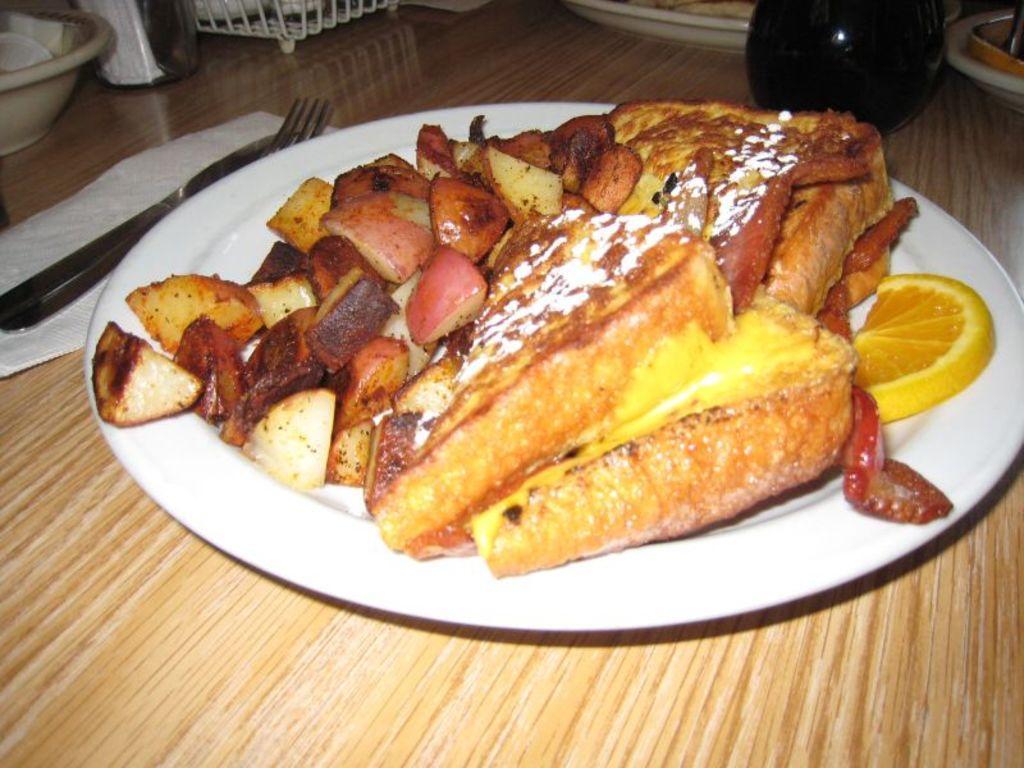Describe this image in one or two sentences. In this picture we can see a plate with food items on it, fork, knife, tissue paper, bowl and some objects and these all are placed on a table. 